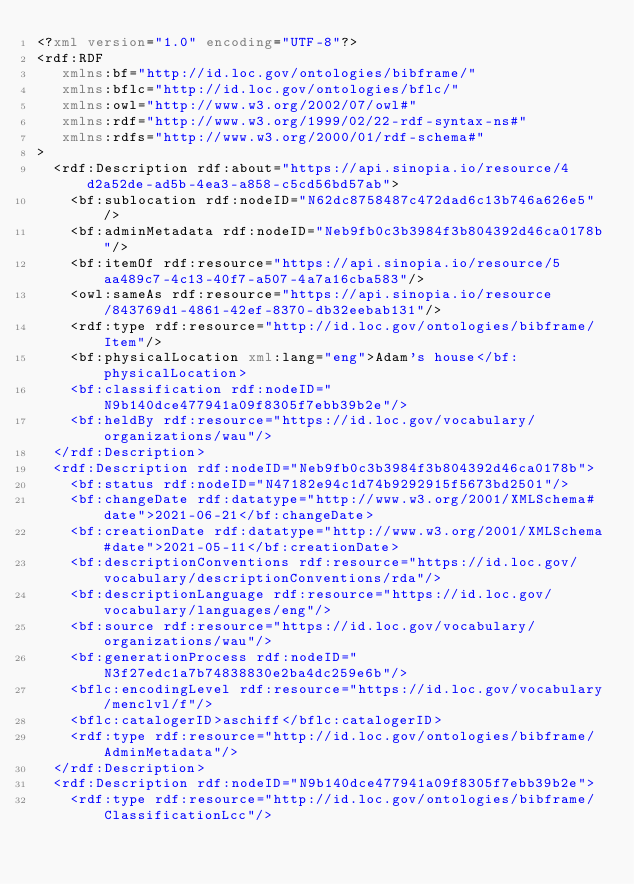Convert code to text. <code><loc_0><loc_0><loc_500><loc_500><_XML_><?xml version="1.0" encoding="UTF-8"?>
<rdf:RDF
   xmlns:bf="http://id.loc.gov/ontologies/bibframe/"
   xmlns:bflc="http://id.loc.gov/ontologies/bflc/"
   xmlns:owl="http://www.w3.org/2002/07/owl#"
   xmlns:rdf="http://www.w3.org/1999/02/22-rdf-syntax-ns#"
   xmlns:rdfs="http://www.w3.org/2000/01/rdf-schema#"
>
  <rdf:Description rdf:about="https://api.sinopia.io/resource/4d2a52de-ad5b-4ea3-a858-c5cd56bd57ab">
    <bf:sublocation rdf:nodeID="N62dc8758487c472dad6c13b746a626e5"/>
    <bf:adminMetadata rdf:nodeID="Neb9fb0c3b3984f3b804392d46ca0178b"/>
    <bf:itemOf rdf:resource="https://api.sinopia.io/resource/5aa489c7-4c13-40f7-a507-4a7a16cba583"/>
    <owl:sameAs rdf:resource="https://api.sinopia.io/resource/843769d1-4861-42ef-8370-db32eebab131"/>
    <rdf:type rdf:resource="http://id.loc.gov/ontologies/bibframe/Item"/>
    <bf:physicalLocation xml:lang="eng">Adam's house</bf:physicalLocation>
    <bf:classification rdf:nodeID="N9b140dce477941a09f8305f7ebb39b2e"/>
    <bf:heldBy rdf:resource="https://id.loc.gov/vocabulary/organizations/wau"/>
  </rdf:Description>
  <rdf:Description rdf:nodeID="Neb9fb0c3b3984f3b804392d46ca0178b">
    <bf:status rdf:nodeID="N47182e94c1d74b9292915f5673bd2501"/>
    <bf:changeDate rdf:datatype="http://www.w3.org/2001/XMLSchema#date">2021-06-21</bf:changeDate>
    <bf:creationDate rdf:datatype="http://www.w3.org/2001/XMLSchema#date">2021-05-11</bf:creationDate>
    <bf:descriptionConventions rdf:resource="https://id.loc.gov/vocabulary/descriptionConventions/rda"/>
    <bf:descriptionLanguage rdf:resource="https://id.loc.gov/vocabulary/languages/eng"/>
    <bf:source rdf:resource="https://id.loc.gov/vocabulary/organizations/wau"/>
    <bf:generationProcess rdf:nodeID="N3f27edc1a7b74838830e2ba4dc259e6b"/>
    <bflc:encodingLevel rdf:resource="https://id.loc.gov/vocabulary/menclvl/f"/>
    <bflc:catalogerID>aschiff</bflc:catalogerID>
    <rdf:type rdf:resource="http://id.loc.gov/ontologies/bibframe/AdminMetadata"/>
  </rdf:Description>
  <rdf:Description rdf:nodeID="N9b140dce477941a09f8305f7ebb39b2e">
    <rdf:type rdf:resource="http://id.loc.gov/ontologies/bibframe/ClassificationLcc"/></code> 